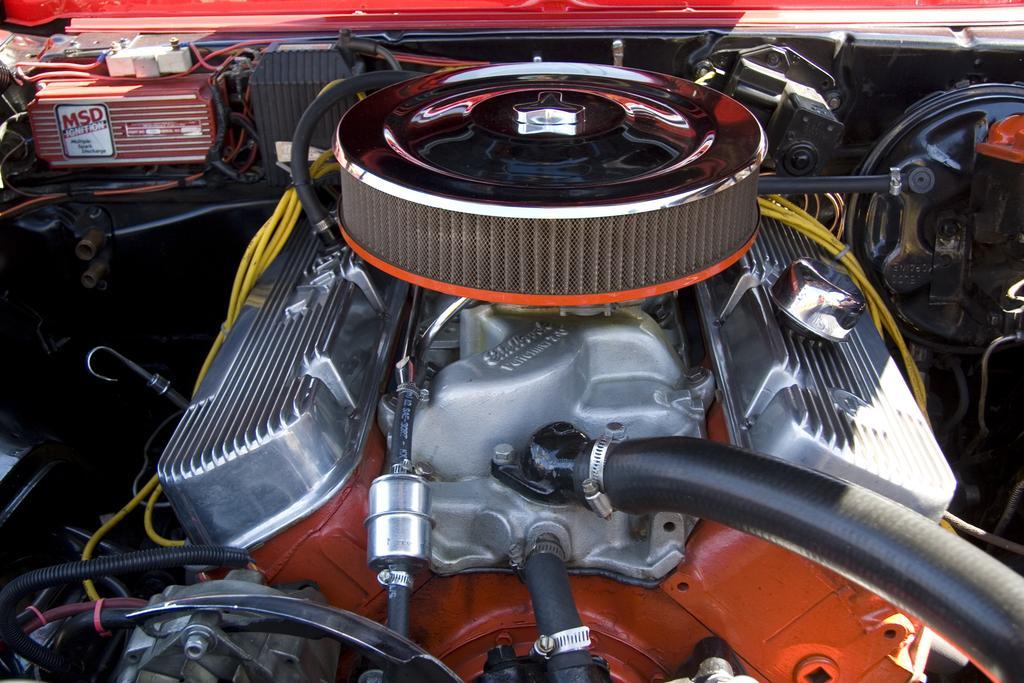In one or two sentences, can you explain what this image depicts? This image consists of an engine of a vehicle. In the front, there is a radiator along with pipes and wires. 